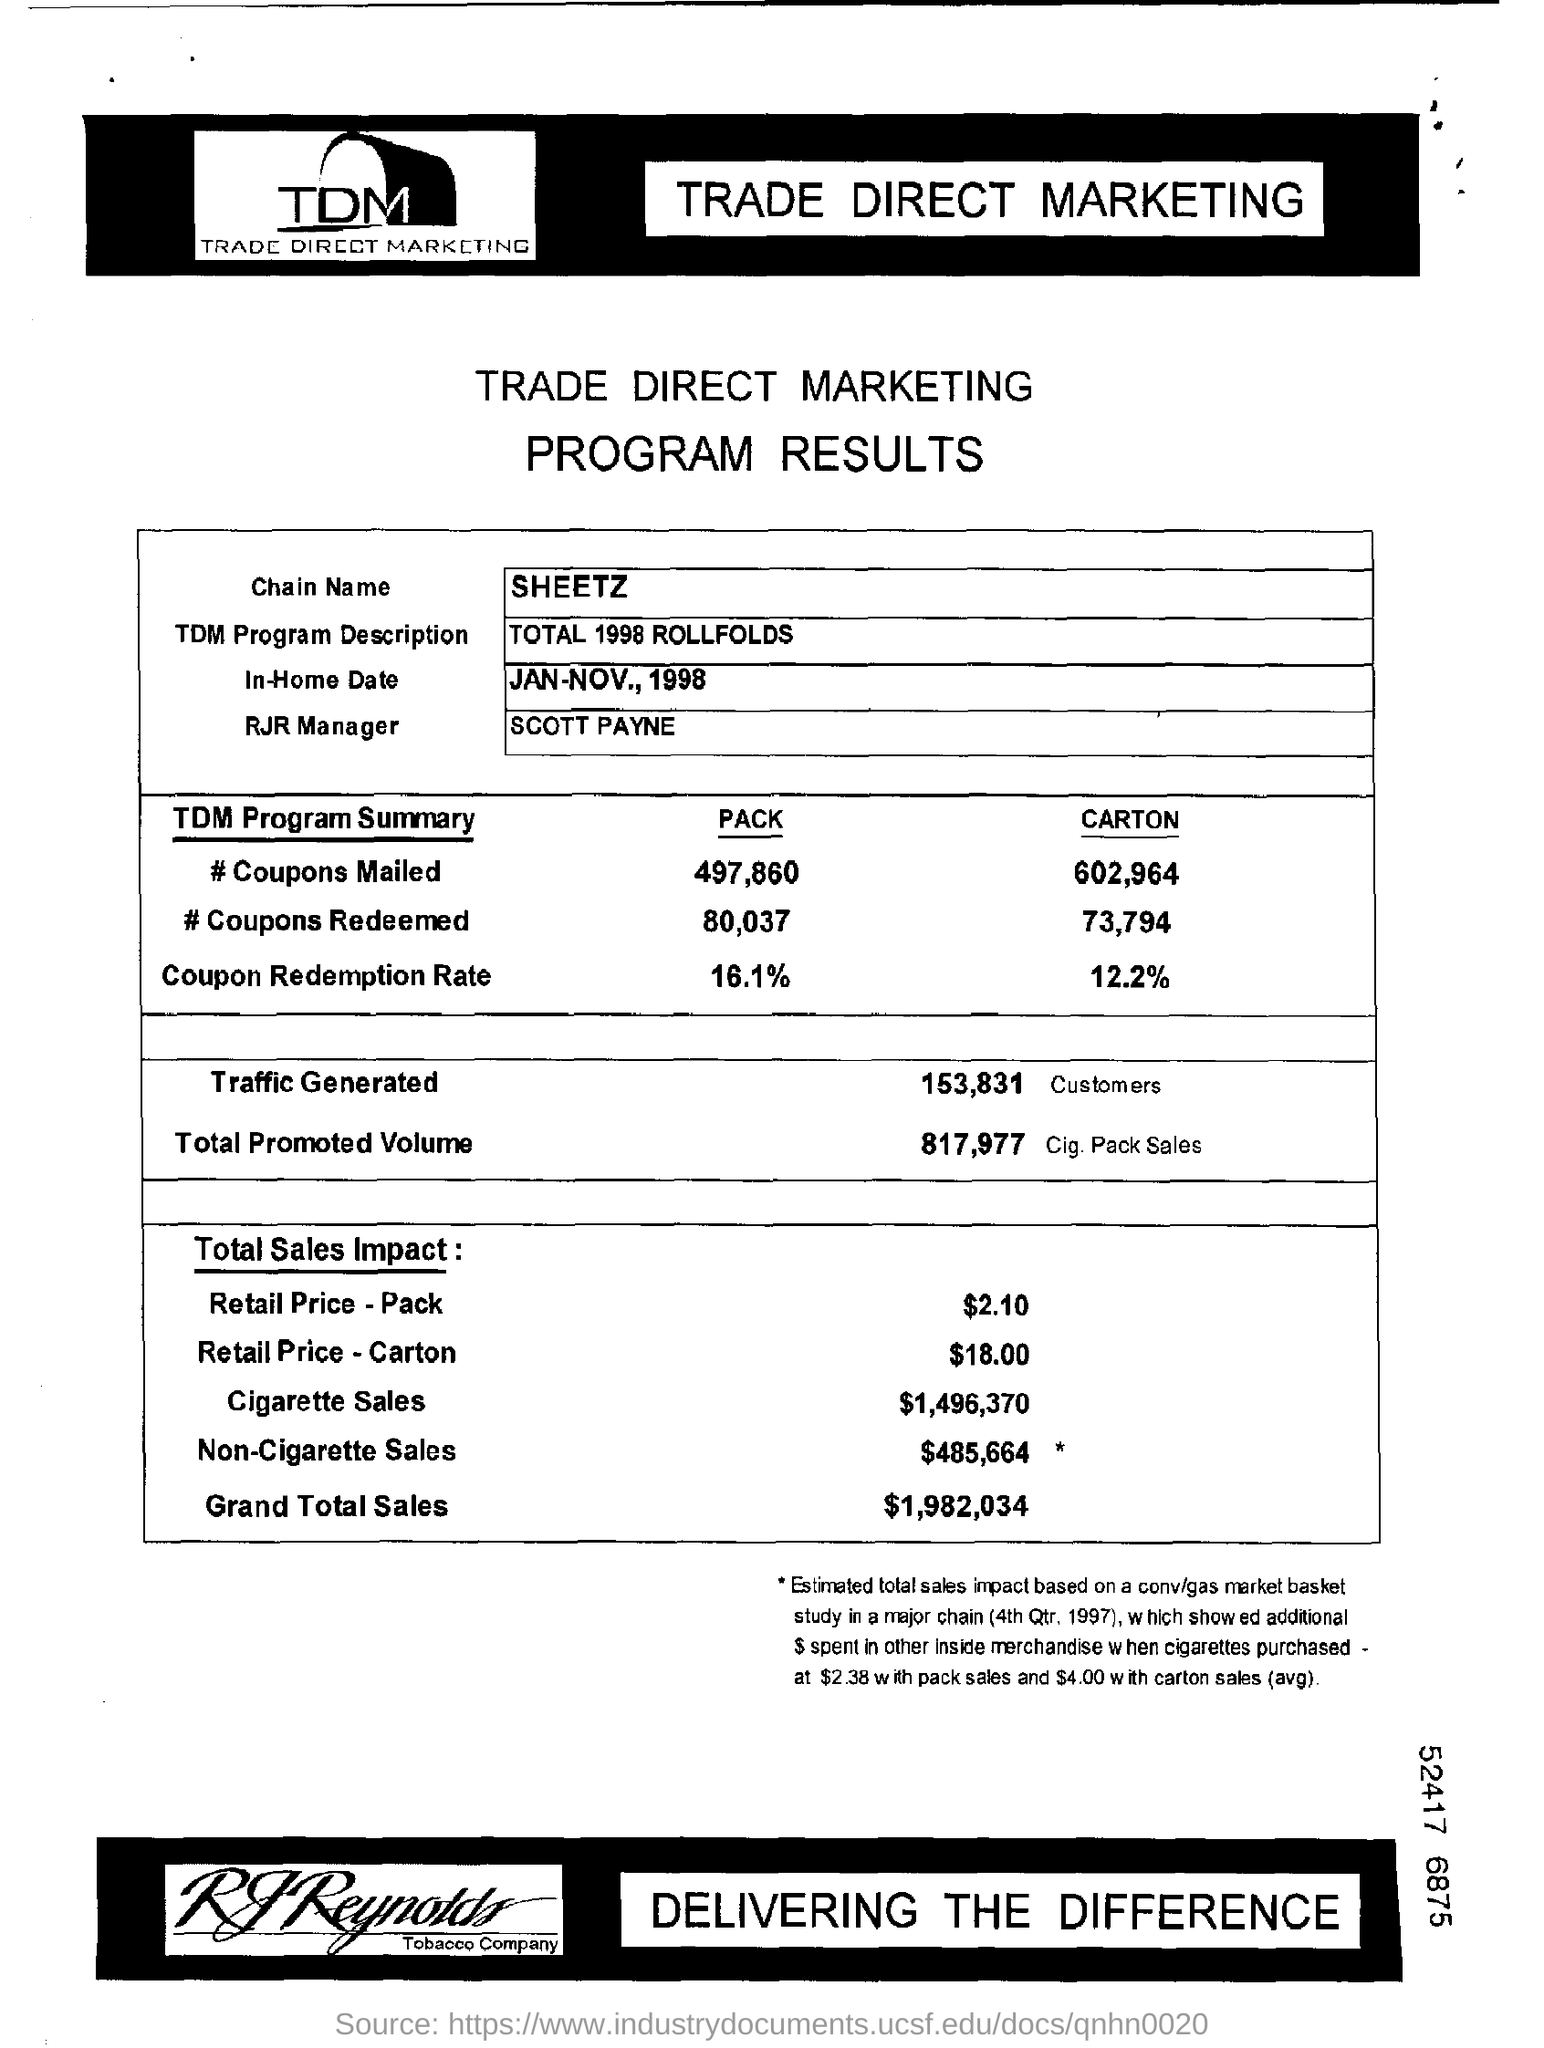What does tdm stands for?
Make the answer very short. Trade direct marketing. Who is the rjr manager ?
Offer a terse response. Scott payne. What is the in-home date?
Your response must be concise. JAN-NOV., 1998. How much of traffic is  generated?
Your response must be concise. 153,831. What is the total promoted volume?
Your answer should be very brief. 817,977. How much is the amount of "cigarette sales"?
Ensure brevity in your answer.  $1,496,370. How much amount for grand total sales under the "total sales impact"?
Give a very brief answer. $1,982,034. 